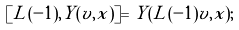<formula> <loc_0><loc_0><loc_500><loc_500>[ L ( - 1 ) , Y ( v , x ) ] = Y ( L ( - 1 ) v , x ) ;</formula> 